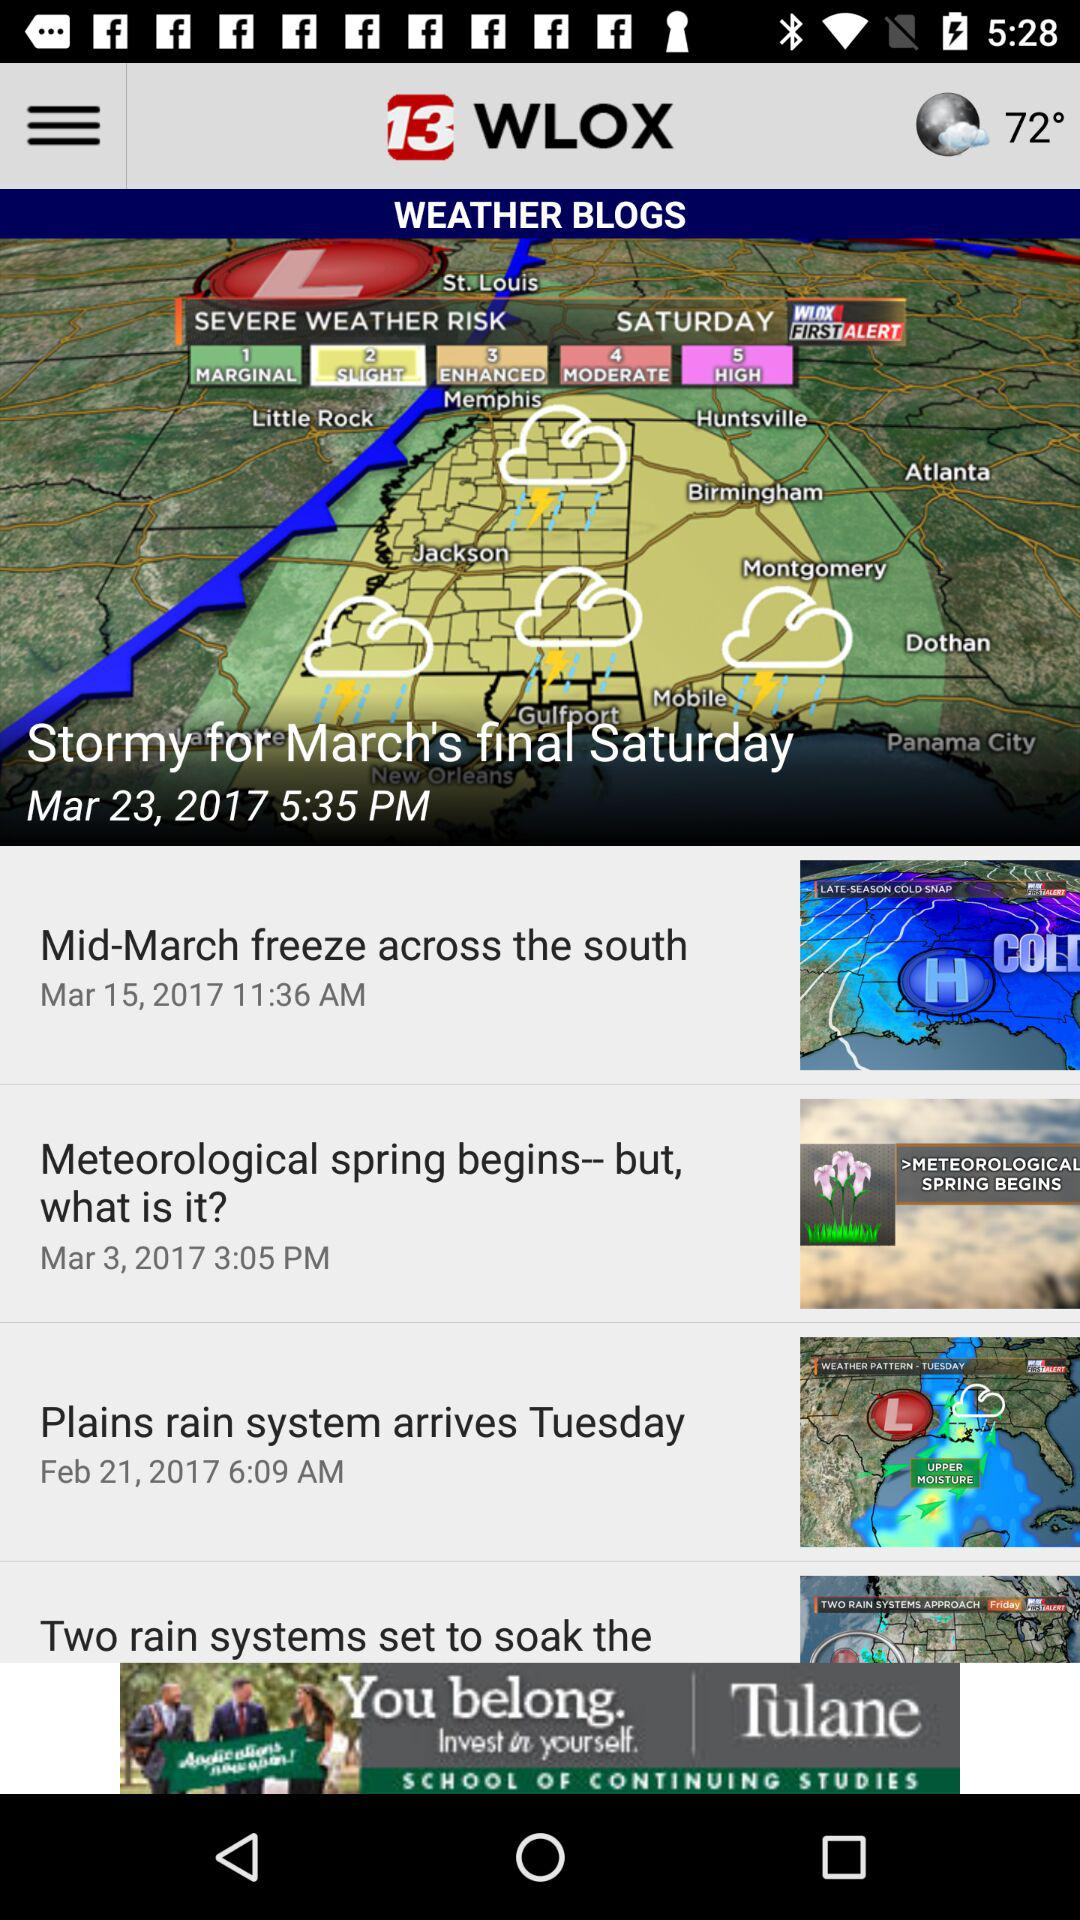What is the publication date of the weather blog "Mid-March freeze across the south"? The publication date of the weather blog "Mid-March freeze across the south" is March 15, 2017. 